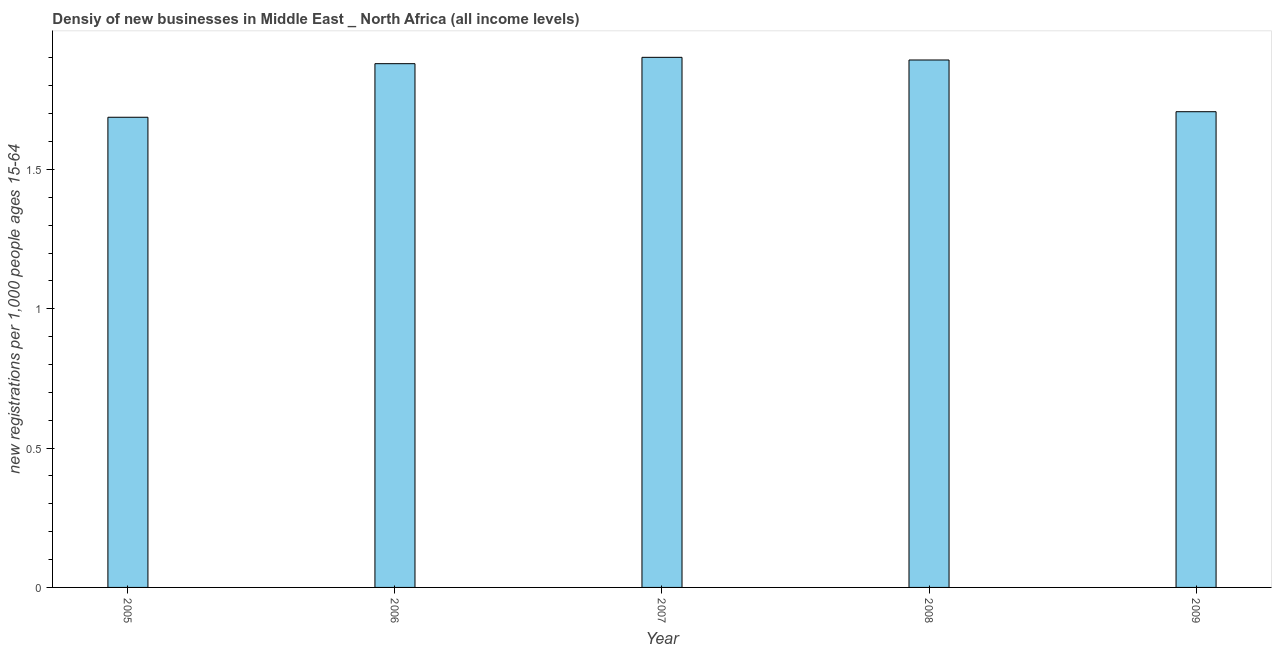Does the graph contain any zero values?
Ensure brevity in your answer.  No. Does the graph contain grids?
Your response must be concise. No. What is the title of the graph?
Ensure brevity in your answer.  Densiy of new businesses in Middle East _ North Africa (all income levels). What is the label or title of the Y-axis?
Your answer should be very brief. New registrations per 1,0 people ages 15-64. What is the density of new business in 2008?
Offer a very short reply. 1.89. Across all years, what is the maximum density of new business?
Your answer should be very brief. 1.9. Across all years, what is the minimum density of new business?
Your answer should be compact. 1.69. In which year was the density of new business maximum?
Offer a very short reply. 2007. What is the sum of the density of new business?
Provide a short and direct response. 9.07. What is the difference between the density of new business in 2006 and 2009?
Offer a terse response. 0.17. What is the average density of new business per year?
Your response must be concise. 1.81. What is the median density of new business?
Make the answer very short. 1.88. Do a majority of the years between 2009 and 2005 (inclusive) have density of new business greater than 1 ?
Your answer should be very brief. Yes. What is the ratio of the density of new business in 2005 to that in 2008?
Your answer should be compact. 0.89. What is the difference between the highest and the second highest density of new business?
Offer a very short reply. 0.01. Is the sum of the density of new business in 2005 and 2007 greater than the maximum density of new business across all years?
Your response must be concise. Yes. What is the difference between the highest and the lowest density of new business?
Your answer should be very brief. 0.22. In how many years, is the density of new business greater than the average density of new business taken over all years?
Your answer should be very brief. 3. How many bars are there?
Offer a terse response. 5. Are all the bars in the graph horizontal?
Ensure brevity in your answer.  No. How many years are there in the graph?
Offer a very short reply. 5. Are the values on the major ticks of Y-axis written in scientific E-notation?
Keep it short and to the point. No. What is the new registrations per 1,000 people ages 15-64 of 2005?
Your answer should be very brief. 1.69. What is the new registrations per 1,000 people ages 15-64 of 2006?
Your response must be concise. 1.88. What is the new registrations per 1,000 people ages 15-64 of 2007?
Offer a very short reply. 1.9. What is the new registrations per 1,000 people ages 15-64 in 2008?
Keep it short and to the point. 1.89. What is the new registrations per 1,000 people ages 15-64 of 2009?
Your answer should be compact. 1.71. What is the difference between the new registrations per 1,000 people ages 15-64 in 2005 and 2006?
Your response must be concise. -0.19. What is the difference between the new registrations per 1,000 people ages 15-64 in 2005 and 2007?
Provide a short and direct response. -0.22. What is the difference between the new registrations per 1,000 people ages 15-64 in 2005 and 2008?
Your answer should be very brief. -0.21. What is the difference between the new registrations per 1,000 people ages 15-64 in 2005 and 2009?
Provide a succinct answer. -0.02. What is the difference between the new registrations per 1,000 people ages 15-64 in 2006 and 2007?
Offer a very short reply. -0.02. What is the difference between the new registrations per 1,000 people ages 15-64 in 2006 and 2008?
Provide a succinct answer. -0.01. What is the difference between the new registrations per 1,000 people ages 15-64 in 2006 and 2009?
Your answer should be compact. 0.17. What is the difference between the new registrations per 1,000 people ages 15-64 in 2007 and 2008?
Your answer should be compact. 0.01. What is the difference between the new registrations per 1,000 people ages 15-64 in 2007 and 2009?
Make the answer very short. 0.2. What is the difference between the new registrations per 1,000 people ages 15-64 in 2008 and 2009?
Provide a succinct answer. 0.19. What is the ratio of the new registrations per 1,000 people ages 15-64 in 2005 to that in 2006?
Make the answer very short. 0.9. What is the ratio of the new registrations per 1,000 people ages 15-64 in 2005 to that in 2007?
Ensure brevity in your answer.  0.89. What is the ratio of the new registrations per 1,000 people ages 15-64 in 2005 to that in 2008?
Keep it short and to the point. 0.89. What is the ratio of the new registrations per 1,000 people ages 15-64 in 2005 to that in 2009?
Offer a terse response. 0.99. What is the ratio of the new registrations per 1,000 people ages 15-64 in 2006 to that in 2009?
Offer a very short reply. 1.1. What is the ratio of the new registrations per 1,000 people ages 15-64 in 2007 to that in 2009?
Provide a succinct answer. 1.11. What is the ratio of the new registrations per 1,000 people ages 15-64 in 2008 to that in 2009?
Make the answer very short. 1.11. 